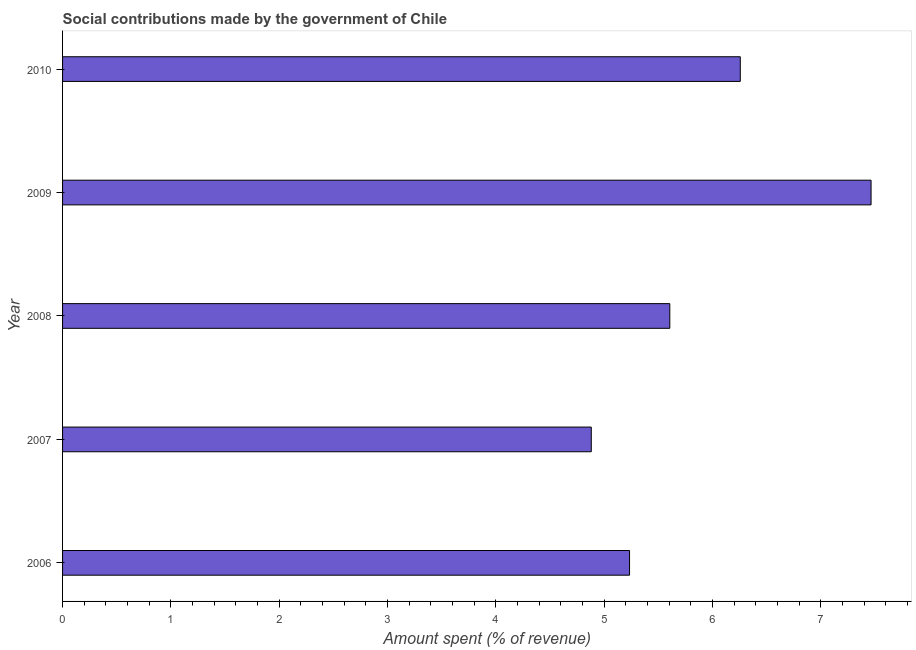Does the graph contain any zero values?
Keep it short and to the point. No. What is the title of the graph?
Give a very brief answer. Social contributions made by the government of Chile. What is the label or title of the X-axis?
Provide a short and direct response. Amount spent (% of revenue). What is the amount spent in making social contributions in 2006?
Make the answer very short. 5.23. Across all years, what is the maximum amount spent in making social contributions?
Ensure brevity in your answer.  7.46. Across all years, what is the minimum amount spent in making social contributions?
Your answer should be compact. 4.88. In which year was the amount spent in making social contributions minimum?
Your answer should be very brief. 2007. What is the sum of the amount spent in making social contributions?
Offer a terse response. 29.44. What is the difference between the amount spent in making social contributions in 2008 and 2010?
Ensure brevity in your answer.  -0.65. What is the average amount spent in making social contributions per year?
Ensure brevity in your answer.  5.89. What is the median amount spent in making social contributions?
Provide a succinct answer. 5.61. In how many years, is the amount spent in making social contributions greater than 5.4 %?
Offer a very short reply. 3. Do a majority of the years between 2006 and 2010 (inclusive) have amount spent in making social contributions greater than 5.2 %?
Your response must be concise. Yes. What is the ratio of the amount spent in making social contributions in 2008 to that in 2009?
Your answer should be very brief. 0.75. Is the amount spent in making social contributions in 2006 less than that in 2009?
Provide a succinct answer. Yes. What is the difference between the highest and the second highest amount spent in making social contributions?
Make the answer very short. 1.21. Is the sum of the amount spent in making social contributions in 2006 and 2007 greater than the maximum amount spent in making social contributions across all years?
Ensure brevity in your answer.  Yes. What is the difference between the highest and the lowest amount spent in making social contributions?
Your answer should be compact. 2.58. In how many years, is the amount spent in making social contributions greater than the average amount spent in making social contributions taken over all years?
Offer a terse response. 2. Are all the bars in the graph horizontal?
Provide a short and direct response. Yes. Are the values on the major ticks of X-axis written in scientific E-notation?
Ensure brevity in your answer.  No. What is the Amount spent (% of revenue) of 2006?
Offer a terse response. 5.23. What is the Amount spent (% of revenue) in 2007?
Your answer should be compact. 4.88. What is the Amount spent (% of revenue) in 2008?
Your response must be concise. 5.61. What is the Amount spent (% of revenue) in 2009?
Ensure brevity in your answer.  7.46. What is the Amount spent (% of revenue) of 2010?
Offer a very short reply. 6.26. What is the difference between the Amount spent (% of revenue) in 2006 and 2007?
Offer a very short reply. 0.35. What is the difference between the Amount spent (% of revenue) in 2006 and 2008?
Ensure brevity in your answer.  -0.37. What is the difference between the Amount spent (% of revenue) in 2006 and 2009?
Your response must be concise. -2.23. What is the difference between the Amount spent (% of revenue) in 2006 and 2010?
Give a very brief answer. -1.02. What is the difference between the Amount spent (% of revenue) in 2007 and 2008?
Keep it short and to the point. -0.72. What is the difference between the Amount spent (% of revenue) in 2007 and 2009?
Keep it short and to the point. -2.58. What is the difference between the Amount spent (% of revenue) in 2007 and 2010?
Give a very brief answer. -1.38. What is the difference between the Amount spent (% of revenue) in 2008 and 2009?
Ensure brevity in your answer.  -1.86. What is the difference between the Amount spent (% of revenue) in 2008 and 2010?
Give a very brief answer. -0.65. What is the difference between the Amount spent (% of revenue) in 2009 and 2010?
Keep it short and to the point. 1.21. What is the ratio of the Amount spent (% of revenue) in 2006 to that in 2007?
Provide a succinct answer. 1.07. What is the ratio of the Amount spent (% of revenue) in 2006 to that in 2008?
Give a very brief answer. 0.93. What is the ratio of the Amount spent (% of revenue) in 2006 to that in 2009?
Give a very brief answer. 0.7. What is the ratio of the Amount spent (% of revenue) in 2006 to that in 2010?
Ensure brevity in your answer.  0.84. What is the ratio of the Amount spent (% of revenue) in 2007 to that in 2008?
Provide a short and direct response. 0.87. What is the ratio of the Amount spent (% of revenue) in 2007 to that in 2009?
Provide a short and direct response. 0.65. What is the ratio of the Amount spent (% of revenue) in 2007 to that in 2010?
Keep it short and to the point. 0.78. What is the ratio of the Amount spent (% of revenue) in 2008 to that in 2009?
Offer a very short reply. 0.75. What is the ratio of the Amount spent (% of revenue) in 2008 to that in 2010?
Make the answer very short. 0.9. What is the ratio of the Amount spent (% of revenue) in 2009 to that in 2010?
Your response must be concise. 1.19. 